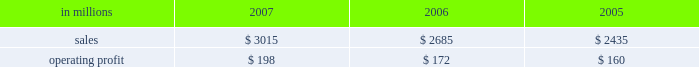Asian industrial packaging net sales for 2007 were $ 265 million compared with $ 180 million in 2006 .
In 2005 , net sales were $ 105 million sub- sequent to international paper 2019s acquisition of a majority interest in this business in august 2005 .
Operating profits totaled $ 6 million in 2007 and $ 3 million in 2006 , compared with a loss of $ 4 million in consumer packaging demand and pricing for consumer packaging prod- ucts correlate closely with consumer spending and general economic activity .
In addition to prices and volumes , major factors affecting the profitability of consumer packaging are raw material and energy costs , freight costs , manufacturing efficiency and product mix .
Consumer packaging net sales increased 12% ( 12 % ) compared with 2006 and 24% ( 24 % ) compared with 2005 .
Operating profits rose 15% ( 15 % ) from 2006 and 24% ( 24 % ) from 2005 levels .
Benefits from improved average sales price realizations ( $ 52 million ) , higher sales volumes for u.s .
And european coated paperboard ( $ 9 million ) , favorable mill operations ( $ 14 million ) and contributions from international paper & sun cartonboard co. , ltd .
Acquired in 2006 ( $ 16 million ) , were partially offset by higher raw material and energy costs ( $ 53 million ) , an unfavorable mix of products sold ( $ 4 million ) , increased freight costs ( $ 5 million ) and other costs ( $ 3 million ) .
Consumer packaging in millions 2007 2006 2005 .
North american consumer packaging net sales were $ 2.4 billion in both 2007 and 2006 com- pared with $ 2.2 billion in 2005 .
Operating earnings of $ 143 million in 2007 improved from $ 129 million in 2006 and $ 121 million in 2005 .
Coated paperboard sales volumes increased in 2007 compared with 2006 , particularly for folding carton board , reflecting improved demand .
Average sales price realizations substantially improved in 2007 for both folding carton board and cup stock .
The impact of the higher sales prices combined with improved manufacturing performance at our mills more than offset the negative effects of higher wood and energy costs .
Foodservice sales volumes were slightly higher in 2007 than in 2006 .
Average sales prices were also higher reflecting the realization of price increases implemented to recover raw material cost increases .
In addition , a more favorable mix of hot cups and food containers led to higher average margins .
Raw material costs for bleached board and polystyrene were higher than in 2006 , but these increases were partially offset by improved manufacturing costs reflecting increased productivity and reduced waste .
Shorewood sales volumes in 2007 declined from 2006 levels due to weak demand in the home enter- tainment , tobacco and display markets , although demand was stronger in the consumer products segment .
Sales margins declined from 2006 reflect- ing a less favorable mix of products sold .
Raw material costs were higher for bleached board , but this impact was more than offset by improved manufacturing operations and lower operating costs .
Charges to restructure operations also impacted 2007 results .
Entering 2008 , coated paperboard sales volumes are expected to be about even with the fourth quarter of 2007 , while average sales price realizations are expected to slightly improve .
Earnings should bene- fit from fewer planned mill maintenance outages compared with the 2007 fourth quarter .
However , costs for wood , polyethylene and energy are expected to be higher .
Foodservice results are expected to benefit from increased sales volumes and higher sales price realizations .
Shorewood sales volumes for the first quarter 2008 are expected to seasonally decline , but this negative impact should be partially offset by benefits from cost improve- ments associated with prior-year restructuring actions .
European consumer packaging net sales in 2007 were $ 280 million compared with $ 230 million in 2006 and $ 190 million in 2005 .
Sales volumes in 2007 were higher than in 2006 reflecting stronger market demand and improved productivity at our kwidzyn mill .
Average sales price realizations also improved in 2007 .
Operating earnings in 2007 of $ 37 million declined from $ 41 million in 2006 and $ 39 million in 2005 .
The additional contribution from higher net sales was more than offset by higher input costs for wood , energy and freight .
Entering 2008 , sales volumes and prices are expected to be comparable to the fourth quarter .
Machine performance and sales mix are expected to improve ; however , wood costs are expected to be higher , especially in russia due to strong demand ahead of tariff increases , and energy costs are anticipated to be seasonally higher. .
What was the percentage decline in the operating earnings in 2007 of $ 37 million declined from $ 41? 
Computations: ((37 - 41) / 41)
Answer: -0.09756. 